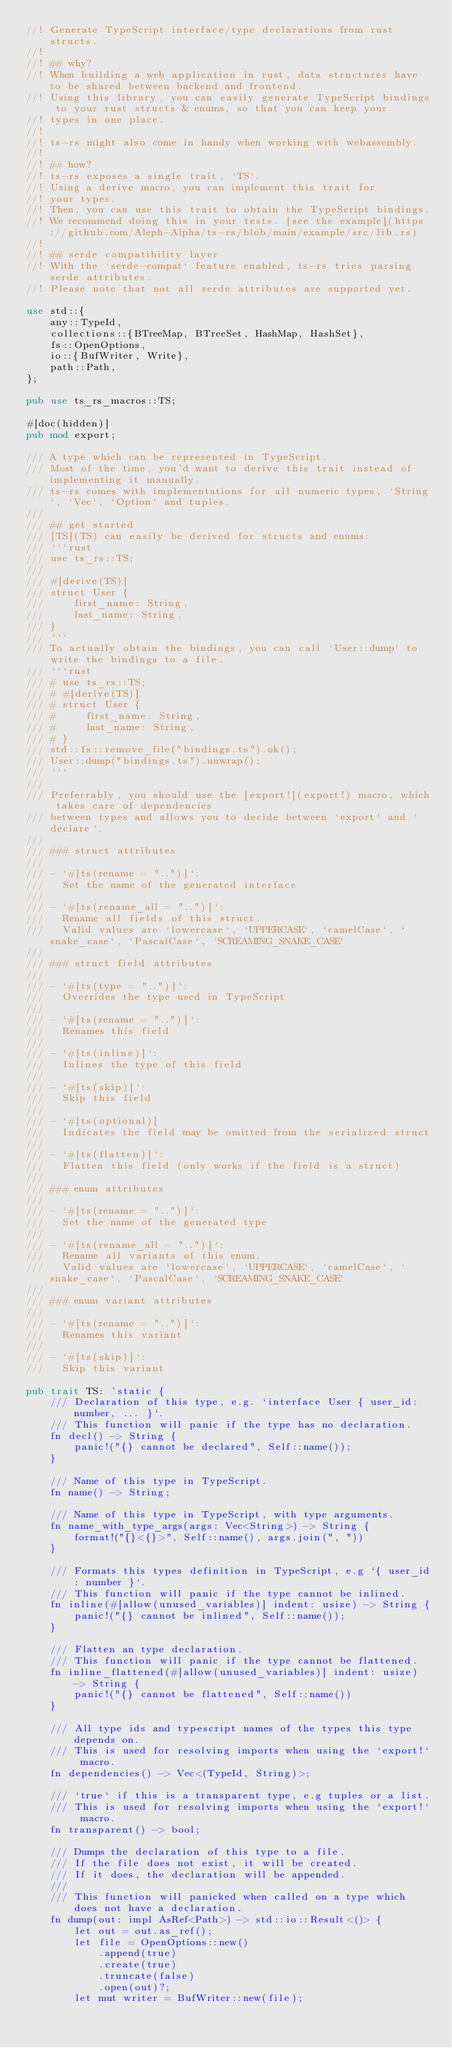<code> <loc_0><loc_0><loc_500><loc_500><_Rust_>//! Generate TypeScript interface/type declarations from rust structs.
//!
//! ## why?
//! When building a web application in rust, data structures have to be shared between backend and frontend.  
//! Using this library, you can easily generate TypeScript bindings to your rust structs & enums, so that you can keep your
//! types in one place.
//!
//! ts-rs might also come in handy when working with webassembly.
//!
//! ## how?
//! ts-rs exposes a single trait, `TS`.  
//! Using a derive macro, you can implement this trait for
//! your types.  
//! Then, you can use this trait to obtain the TypeScript bindings.
//! We recommend doing this in your tests. [see the example](https://github.com/Aleph-Alpha/ts-rs/blob/main/example/src/lib.rs)
//!
//! ## serde compatibility layer
//! With the `serde-compat` feature enabled, ts-rs tries parsing serde attributes.  
//! Please note that not all serde attributes are supported yet.

use std::{
    any::TypeId,
    collections::{BTreeMap, BTreeSet, HashMap, HashSet},
    fs::OpenOptions,
    io::{BufWriter, Write},
    path::Path,
};

pub use ts_rs_macros::TS;

#[doc(hidden)]
pub mod export;

/// A type which can be represented in TypeScript.  
/// Most of the time, you'd want to derive this trait instead of implementing it manually.  
/// ts-rs comes with implementations for all numeric types, `String`, `Vec`, `Option` and tuples.
///
/// ## get started
/// [TS](TS) can easily be derived for structs and enums:
/// ```rust
/// use ts_rs::TS;
///
/// #[derive(TS)]
/// struct User {
///     first_name: String,
///     last_name: String,
/// }
/// ```
/// To actually obtain the bindings, you can call `User::dump` to write the bindings to a file.
/// ```rust
/// # use ts_rs::TS;
/// # #[derive(TS)]
/// # struct User {
/// #     first_name: String,
/// #     last_name: String,
/// # }
/// std::fs::remove_file("bindings.ts").ok();
/// User::dump("bindings.ts").unwrap();
/// ```
///
/// Preferrably, you should use the [export!](export!) macro, which takes care of dependencies
/// between types and allows you to decide between `export` and `declare`.
///
/// ### struct attributes
///
/// - `#[ts(rename = "..")]`:  
///   Set the name of the generated interface  
///
/// - `#[ts(rename_all = "..")]`:  
///   Rename all fields of this struct.  
///   Valid values are `lowercase`, `UPPERCASE`, `camelCase`, `snake_case`, `PascalCase`, `SCREAMING_SNAKE_CASE`
///   
/// ### struct field attributes
///
/// - `#[ts(type = "..")]`:  
///   Overrides the type used in TypeScript  
///
/// - `#[ts(rename = "..")]`:  
///   Renames this field  
///
/// - `#[ts(inline)]`:  
///   Inlines the type of this field  
///
/// - `#[ts(skip)]`:  
///   Skip this field  
///
/// - `#[ts(optional)]
///   Indicates the field may be omitted from the serialized struct
///
/// - `#[ts(flatten)]`:  
///   Flatten this field (only works if the field is a struct)  
///   
/// ### enum attributes
///
/// - `#[ts(rename = "..")]`:  
///   Set the name of the generated type  
///
/// - `#[ts(rename_all = "..")]`:  
///   Rename all variants of this enum.  
///   Valid values are `lowercase`, `UPPERCASE`, `camelCase`, `snake_case`, `PascalCase`, `SCREAMING_SNAKE_CASE`
///  
/// ### enum variant attributes
///
/// - `#[ts(rename = "..")]`:  
///   Renames this variant  
///
/// - `#[ts(skip)]`:  
///   Skip this variant  

pub trait TS: 'static {
    /// Declaration of this type, e.g. `interface User { user_id: number, ... }`.
    /// This function will panic if the type has no declaration.
    fn decl() -> String {
        panic!("{} cannot be declared", Self::name());
    }

    /// Name of this type in TypeScript.
    fn name() -> String;

    /// Name of this type in TypeScript, with type arguments.
    fn name_with_type_args(args: Vec<String>) -> String {
        format!("{}<{}>", Self::name(), args.join(", "))
    }

    /// Formats this types definition in TypeScript, e.g `{ user_id: number }`.
    /// This function will panic if the type cannot be inlined.
    fn inline(#[allow(unused_variables)] indent: usize) -> String {
        panic!("{} cannot be inlined", Self::name());
    }

    /// Flatten an type declaration.  
    /// This function will panic if the type cannot be flattened.
    fn inline_flattened(#[allow(unused_variables)] indent: usize) -> String {
        panic!("{} cannot be flattened", Self::name())
    }

    /// All type ids and typescript names of the types this type depends on.  
    /// This is used for resolving imports when using the `export!` macro.  
    fn dependencies() -> Vec<(TypeId, String)>;

    /// `true` if this is a transparent type, e.g tuples or a list.  
    /// This is used for resolving imports when using the `export!` macro.
    fn transparent() -> bool;

    /// Dumps the declaration of this type to a file.  
    /// If the file does not exist, it will be created.  
    /// If it does, the declaration will be appended.
    ///
    /// This function will panicked when called on a type which does not have a declaration.
    fn dump(out: impl AsRef<Path>) -> std::io::Result<()> {
        let out = out.as_ref();
        let file = OpenOptions::new()
            .append(true)
            .create(true)
            .truncate(false)
            .open(out)?;
        let mut writer = BufWriter::new(file);</code> 